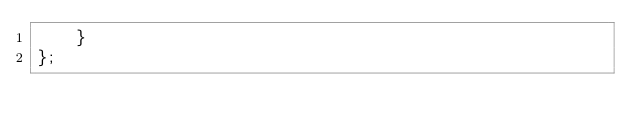<code> <loc_0><loc_0><loc_500><loc_500><_TypeScript_>    }
};
</code> 